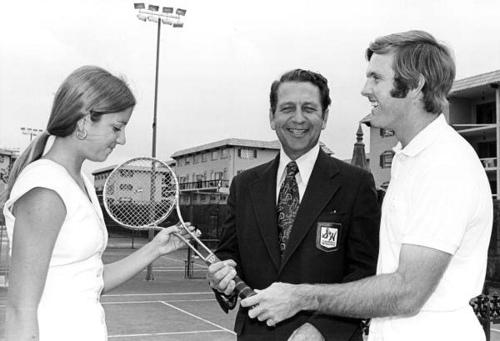How many lights are on each pole?
Short answer required. 8. Does this woman look humbled?
Short answer required. Yes. What game are they playing?
Write a very short answer. Tennis. 